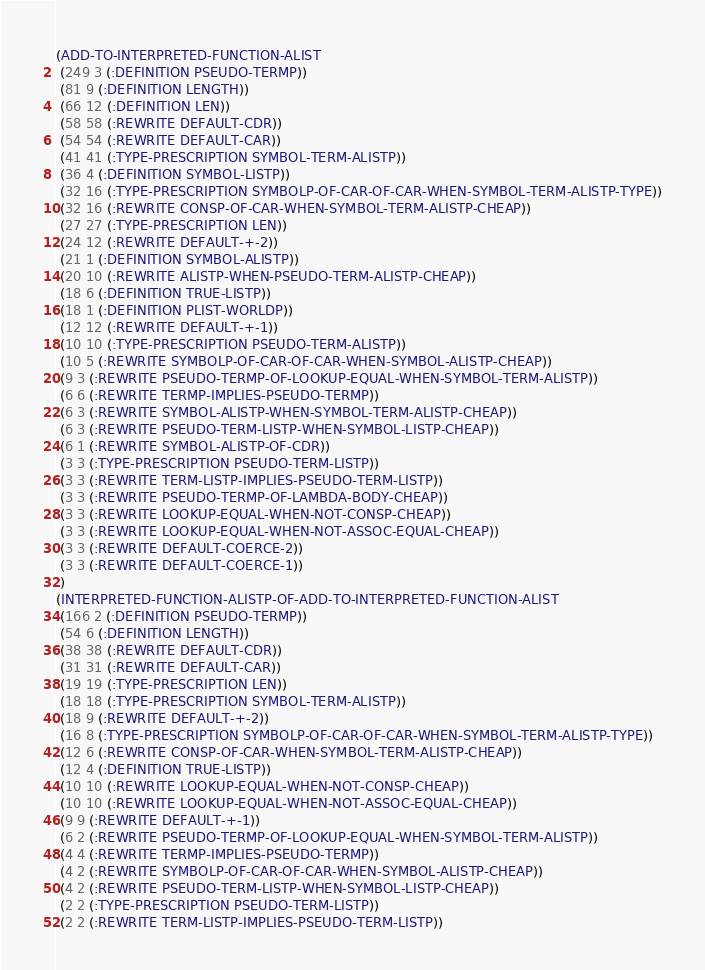<code> <loc_0><loc_0><loc_500><loc_500><_Lisp_>(ADD-TO-INTERPRETED-FUNCTION-ALIST
 (249 3 (:DEFINITION PSEUDO-TERMP))
 (81 9 (:DEFINITION LENGTH))
 (66 12 (:DEFINITION LEN))
 (58 58 (:REWRITE DEFAULT-CDR))
 (54 54 (:REWRITE DEFAULT-CAR))
 (41 41 (:TYPE-PRESCRIPTION SYMBOL-TERM-ALISTP))
 (36 4 (:DEFINITION SYMBOL-LISTP))
 (32 16 (:TYPE-PRESCRIPTION SYMBOLP-OF-CAR-OF-CAR-WHEN-SYMBOL-TERM-ALISTP-TYPE))
 (32 16 (:REWRITE CONSP-OF-CAR-WHEN-SYMBOL-TERM-ALISTP-CHEAP))
 (27 27 (:TYPE-PRESCRIPTION LEN))
 (24 12 (:REWRITE DEFAULT-+-2))
 (21 1 (:DEFINITION SYMBOL-ALISTP))
 (20 10 (:REWRITE ALISTP-WHEN-PSEUDO-TERM-ALISTP-CHEAP))
 (18 6 (:DEFINITION TRUE-LISTP))
 (18 1 (:DEFINITION PLIST-WORLDP))
 (12 12 (:REWRITE DEFAULT-+-1))
 (10 10 (:TYPE-PRESCRIPTION PSEUDO-TERM-ALISTP))
 (10 5 (:REWRITE SYMBOLP-OF-CAR-OF-CAR-WHEN-SYMBOL-ALISTP-CHEAP))
 (9 3 (:REWRITE PSEUDO-TERMP-OF-LOOKUP-EQUAL-WHEN-SYMBOL-TERM-ALISTP))
 (6 6 (:REWRITE TERMP-IMPLIES-PSEUDO-TERMP))
 (6 3 (:REWRITE SYMBOL-ALISTP-WHEN-SYMBOL-TERM-ALISTP-CHEAP))
 (6 3 (:REWRITE PSEUDO-TERM-LISTP-WHEN-SYMBOL-LISTP-CHEAP))
 (6 1 (:REWRITE SYMBOL-ALISTP-OF-CDR))
 (3 3 (:TYPE-PRESCRIPTION PSEUDO-TERM-LISTP))
 (3 3 (:REWRITE TERM-LISTP-IMPLIES-PSEUDO-TERM-LISTP))
 (3 3 (:REWRITE PSEUDO-TERMP-OF-LAMBDA-BODY-CHEAP))
 (3 3 (:REWRITE LOOKUP-EQUAL-WHEN-NOT-CONSP-CHEAP))
 (3 3 (:REWRITE LOOKUP-EQUAL-WHEN-NOT-ASSOC-EQUAL-CHEAP))
 (3 3 (:REWRITE DEFAULT-COERCE-2))
 (3 3 (:REWRITE DEFAULT-COERCE-1))
 )
(INTERPRETED-FUNCTION-ALISTP-OF-ADD-TO-INTERPRETED-FUNCTION-ALIST
 (166 2 (:DEFINITION PSEUDO-TERMP))
 (54 6 (:DEFINITION LENGTH))
 (38 38 (:REWRITE DEFAULT-CDR))
 (31 31 (:REWRITE DEFAULT-CAR))
 (19 19 (:TYPE-PRESCRIPTION LEN))
 (18 18 (:TYPE-PRESCRIPTION SYMBOL-TERM-ALISTP))
 (18 9 (:REWRITE DEFAULT-+-2))
 (16 8 (:TYPE-PRESCRIPTION SYMBOLP-OF-CAR-OF-CAR-WHEN-SYMBOL-TERM-ALISTP-TYPE))
 (12 6 (:REWRITE CONSP-OF-CAR-WHEN-SYMBOL-TERM-ALISTP-CHEAP))
 (12 4 (:DEFINITION TRUE-LISTP))
 (10 10 (:REWRITE LOOKUP-EQUAL-WHEN-NOT-CONSP-CHEAP))
 (10 10 (:REWRITE LOOKUP-EQUAL-WHEN-NOT-ASSOC-EQUAL-CHEAP))
 (9 9 (:REWRITE DEFAULT-+-1))
 (6 2 (:REWRITE PSEUDO-TERMP-OF-LOOKUP-EQUAL-WHEN-SYMBOL-TERM-ALISTP))
 (4 4 (:REWRITE TERMP-IMPLIES-PSEUDO-TERMP))
 (4 2 (:REWRITE SYMBOLP-OF-CAR-OF-CAR-WHEN-SYMBOL-ALISTP-CHEAP))
 (4 2 (:REWRITE PSEUDO-TERM-LISTP-WHEN-SYMBOL-LISTP-CHEAP))
 (2 2 (:TYPE-PRESCRIPTION PSEUDO-TERM-LISTP))
 (2 2 (:REWRITE TERM-LISTP-IMPLIES-PSEUDO-TERM-LISTP))</code> 